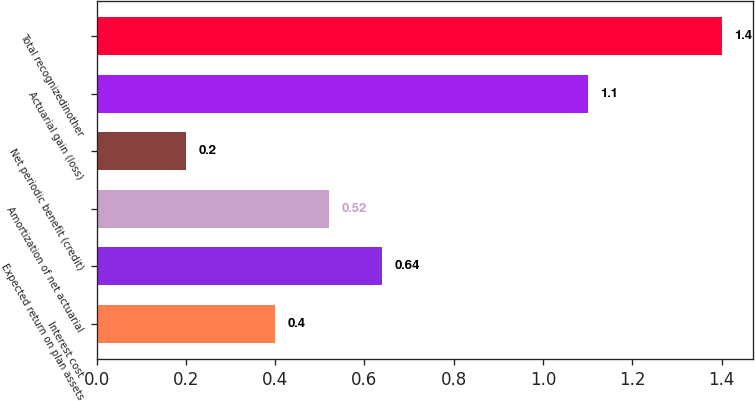Convert chart. <chart><loc_0><loc_0><loc_500><loc_500><bar_chart><fcel>Interest cost<fcel>Expected return on plan assets<fcel>Amortization of net actuarial<fcel>Net periodic benefit (credit)<fcel>Actuarial gain (loss)<fcel>Total recognizedinother<nl><fcel>0.4<fcel>0.64<fcel>0.52<fcel>0.2<fcel>1.1<fcel>1.4<nl></chart> 